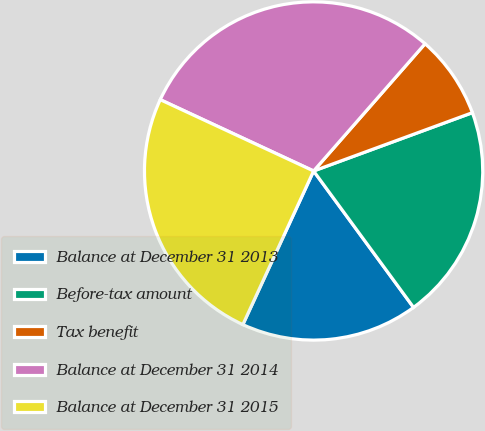Convert chart to OTSL. <chart><loc_0><loc_0><loc_500><loc_500><pie_chart><fcel>Balance at December 31 2013<fcel>Before-tax amount<fcel>Tax benefit<fcel>Balance at December 31 2014<fcel>Balance at December 31 2015<nl><fcel>16.93%<fcel>20.54%<fcel>7.95%<fcel>29.52%<fcel>25.06%<nl></chart> 